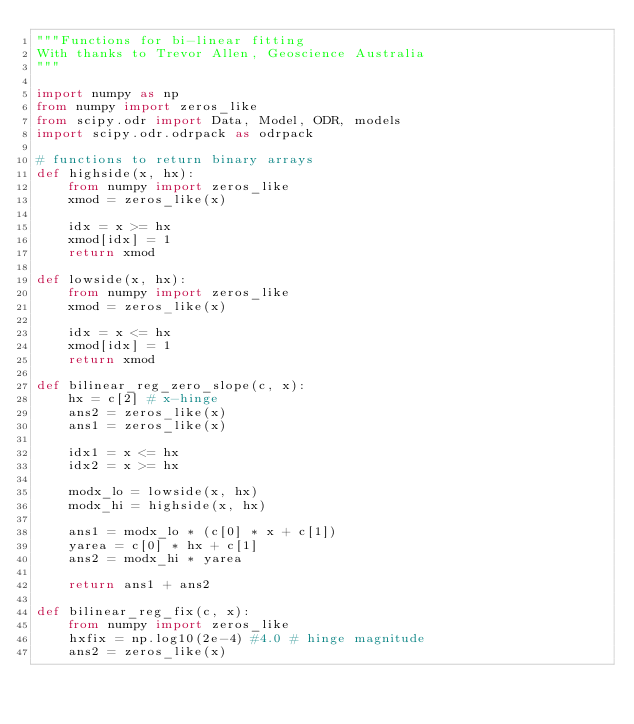Convert code to text. <code><loc_0><loc_0><loc_500><loc_500><_Python_>"""Functions for bi-linear fitting
With thanks to Trevor Allen, Geoscience Australia
"""

import numpy as np
from numpy import zeros_like
from scipy.odr import Data, Model, ODR, models
import scipy.odr.odrpack as odrpack

# functions to return binary arrays
def highside(x, hx):
    from numpy import zeros_like
    xmod = zeros_like(x)
    
    idx = x >= hx
    xmod[idx] = 1
    return xmod
    
def lowside(x, hx):
    from numpy import zeros_like
    xmod = zeros_like(x)
    
    idx = x <= hx
    xmod[idx] = 1
    return xmod

def bilinear_reg_zero_slope(c, x):
    hx = c[2] # x-hinge
    ans2 = zeros_like(x)
    ans1 = zeros_like(x)
    
    idx1 = x <= hx
    idx2 = x >= hx
    
    modx_lo = lowside(x, hx)
    modx_hi = highside(x, hx)
    
    ans1 = modx_lo * (c[0] * x + c[1])
    yarea = c[0] * hx + c[1]
    ans2 = modx_hi * yarea
    
    return ans1 + ans2  

def bilinear_reg_fix(c, x):
    from numpy import zeros_like
    hxfix = np.log10(2e-4) #4.0 # hinge magnitude
    ans2 = zeros_like(x)</code> 